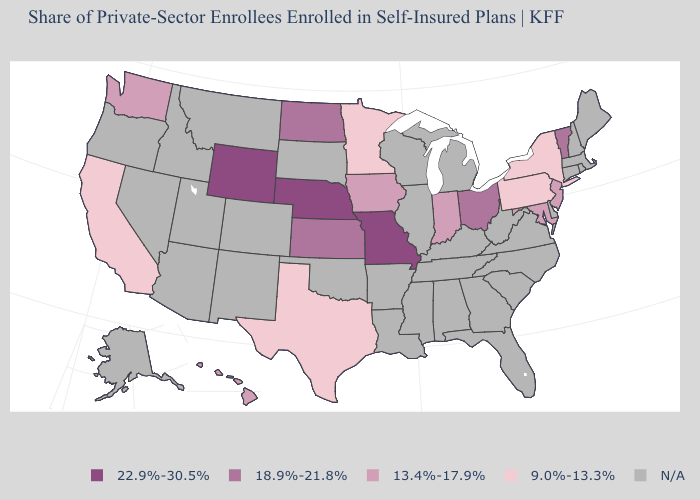Does California have the lowest value in the USA?
Quick response, please. Yes. Name the states that have a value in the range 18.9%-21.8%?
Answer briefly. Kansas, North Dakota, Ohio, Vermont. What is the value of Virginia?
Concise answer only. N/A. Among the states that border Colorado , which have the lowest value?
Short answer required. Kansas. What is the value of Idaho?
Concise answer only. N/A. What is the lowest value in the USA?
Write a very short answer. 9.0%-13.3%. Name the states that have a value in the range 22.9%-30.5%?
Be succinct. Missouri, Nebraska, Wyoming. Which states have the lowest value in the USA?
Give a very brief answer. California, Minnesota, New York, Pennsylvania, Texas. Name the states that have a value in the range 22.9%-30.5%?
Quick response, please. Missouri, Nebraska, Wyoming. Which states hav the highest value in the West?
Quick response, please. Wyoming. Does Nebraska have the highest value in the USA?
Keep it brief. Yes. What is the value of Tennessee?
Concise answer only. N/A. 